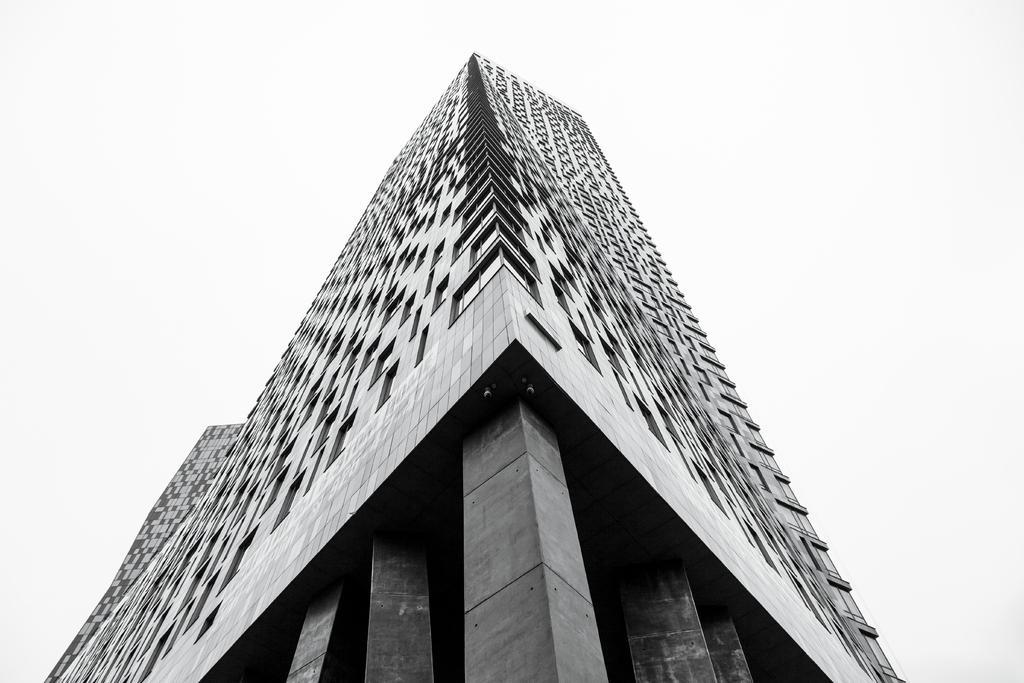Can you describe this image briefly? In this image we can see a building with pillars and a white color background. 